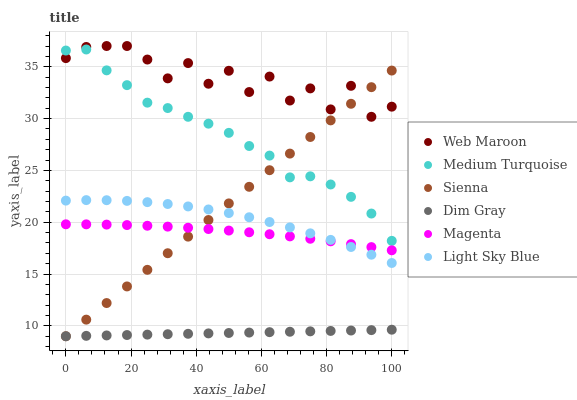Does Dim Gray have the minimum area under the curve?
Answer yes or no. Yes. Does Web Maroon have the maximum area under the curve?
Answer yes or no. Yes. Does Sienna have the minimum area under the curve?
Answer yes or no. No. Does Sienna have the maximum area under the curve?
Answer yes or no. No. Is Dim Gray the smoothest?
Answer yes or no. Yes. Is Web Maroon the roughest?
Answer yes or no. Yes. Is Sienna the smoothest?
Answer yes or no. No. Is Sienna the roughest?
Answer yes or no. No. Does Dim Gray have the lowest value?
Answer yes or no. Yes. Does Web Maroon have the lowest value?
Answer yes or no. No. Does Web Maroon have the highest value?
Answer yes or no. Yes. Does Sienna have the highest value?
Answer yes or no. No. Is Dim Gray less than Medium Turquoise?
Answer yes or no. Yes. Is Magenta greater than Dim Gray?
Answer yes or no. Yes. Does Dim Gray intersect Sienna?
Answer yes or no. Yes. Is Dim Gray less than Sienna?
Answer yes or no. No. Is Dim Gray greater than Sienna?
Answer yes or no. No. Does Dim Gray intersect Medium Turquoise?
Answer yes or no. No. 